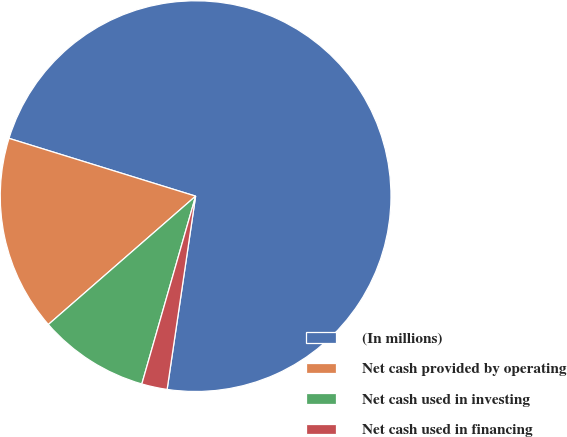Convert chart. <chart><loc_0><loc_0><loc_500><loc_500><pie_chart><fcel>(In millions)<fcel>Net cash provided by operating<fcel>Net cash used in investing<fcel>Net cash used in financing<nl><fcel>72.55%<fcel>16.19%<fcel>9.15%<fcel>2.11%<nl></chart> 